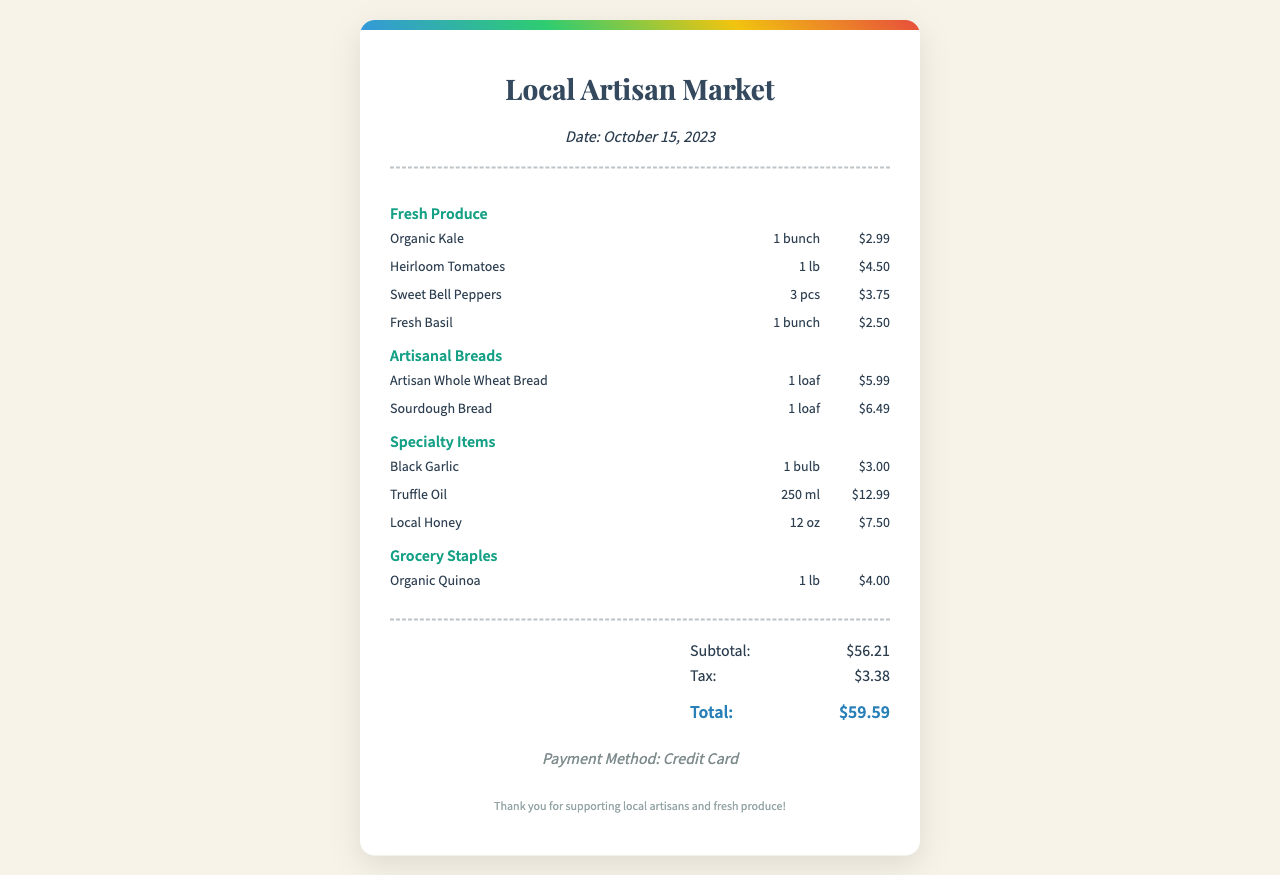what is the date of the receipt? The date of the receipt is provided in the store info section.
Answer: October 15, 2023 how many types of fresh produce are listed? The number of different fresh produce items can be counted in the fresh produce category.
Answer: 4 what is the price of the sourdough bread? The price is indicated next to the item name in the artisanal breads category.
Answer: $6.49 what is the subtotal amount? The subtotal is listed in the totals section directly before tax is calculated.
Answer: $56.21 which specialty item costs the most? By comparing the prices in the specialty items section, the item with the highest cost can be identified.
Answer: Truffle Oil how many bell peppers are purchased? The quantity of sweet bell peppers is noted in the fresh produce section.
Answer: 3 pcs what is the payment method used for this purchase? The payment method is specified in the payment method section of the receipt.
Answer: Credit Card what is the total amount paid? The total amount is clearly stated after the subtotal and tax, summarizing the overall expenditure.
Answer: $59.59 what category does organic quinoa belong to? The item organic quinoa is listed under a specific category among various items on the receipt.
Answer: Grocery Staples 